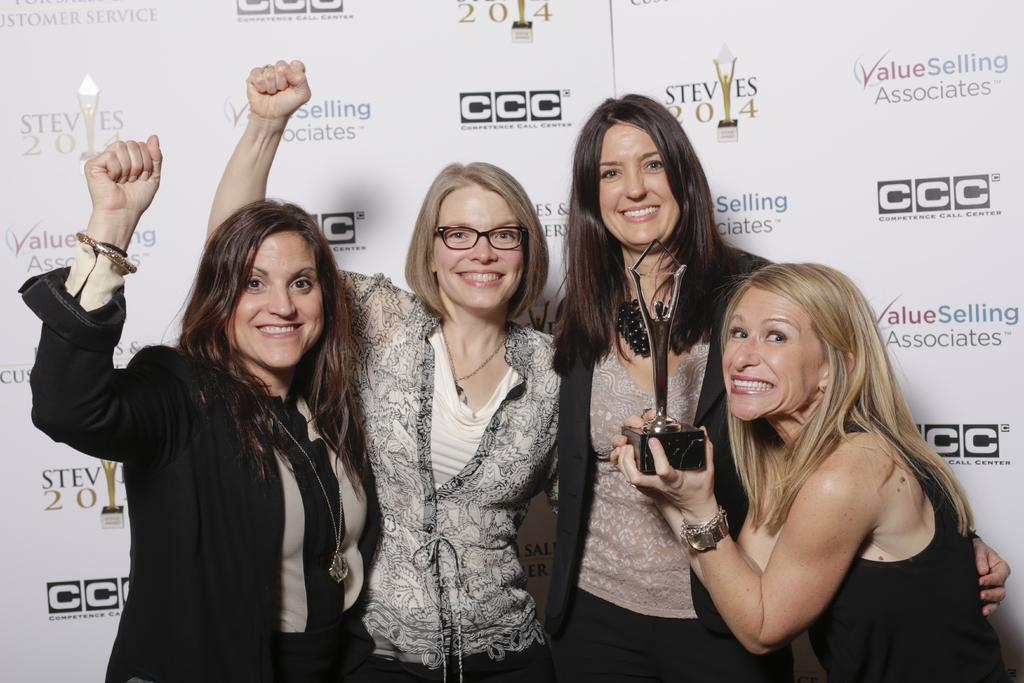How many people are in the image? There are a few people in the image. What is one person doing in the image? One person is holding an object. What can be seen in the background of the image? There are boards with text and images in the background. What religious symbol can be seen in the image? There is no religious symbol present in the image. How deep is the quicksand in the image? There is no quicksand present in the image. 